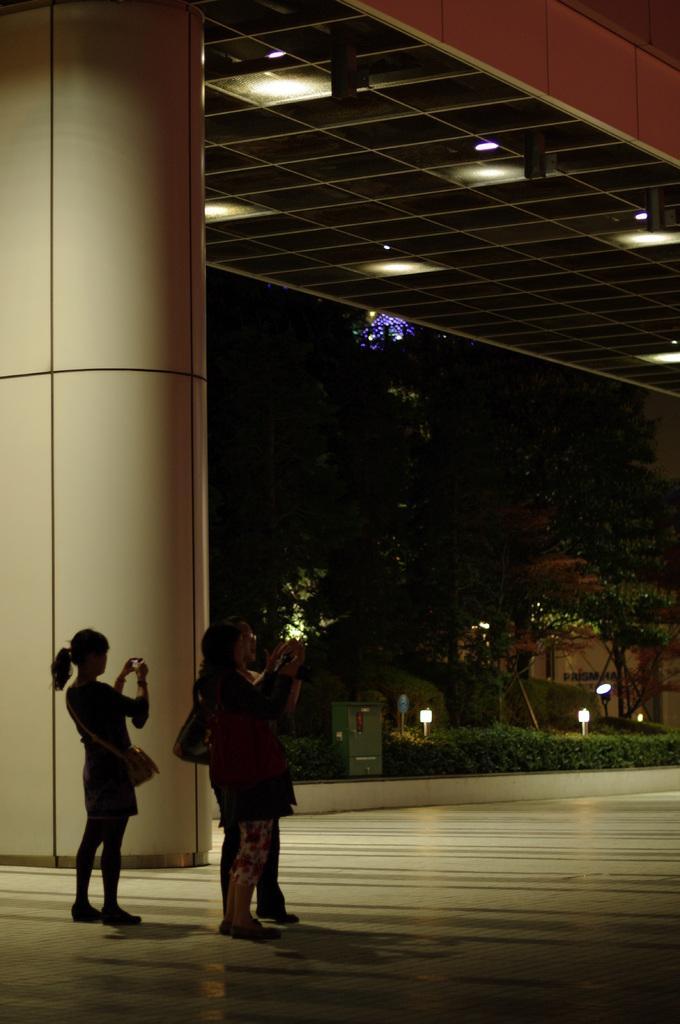Describe this image in one or two sentences. In this image there are some people standing, and they are holding mobile phones and wearing bags. At the bottom there is floor, and in the background there are some buildings, lights, plants and some box. On the left side of the image there is a pillar. At the top there might be a ceiling and some lights. 